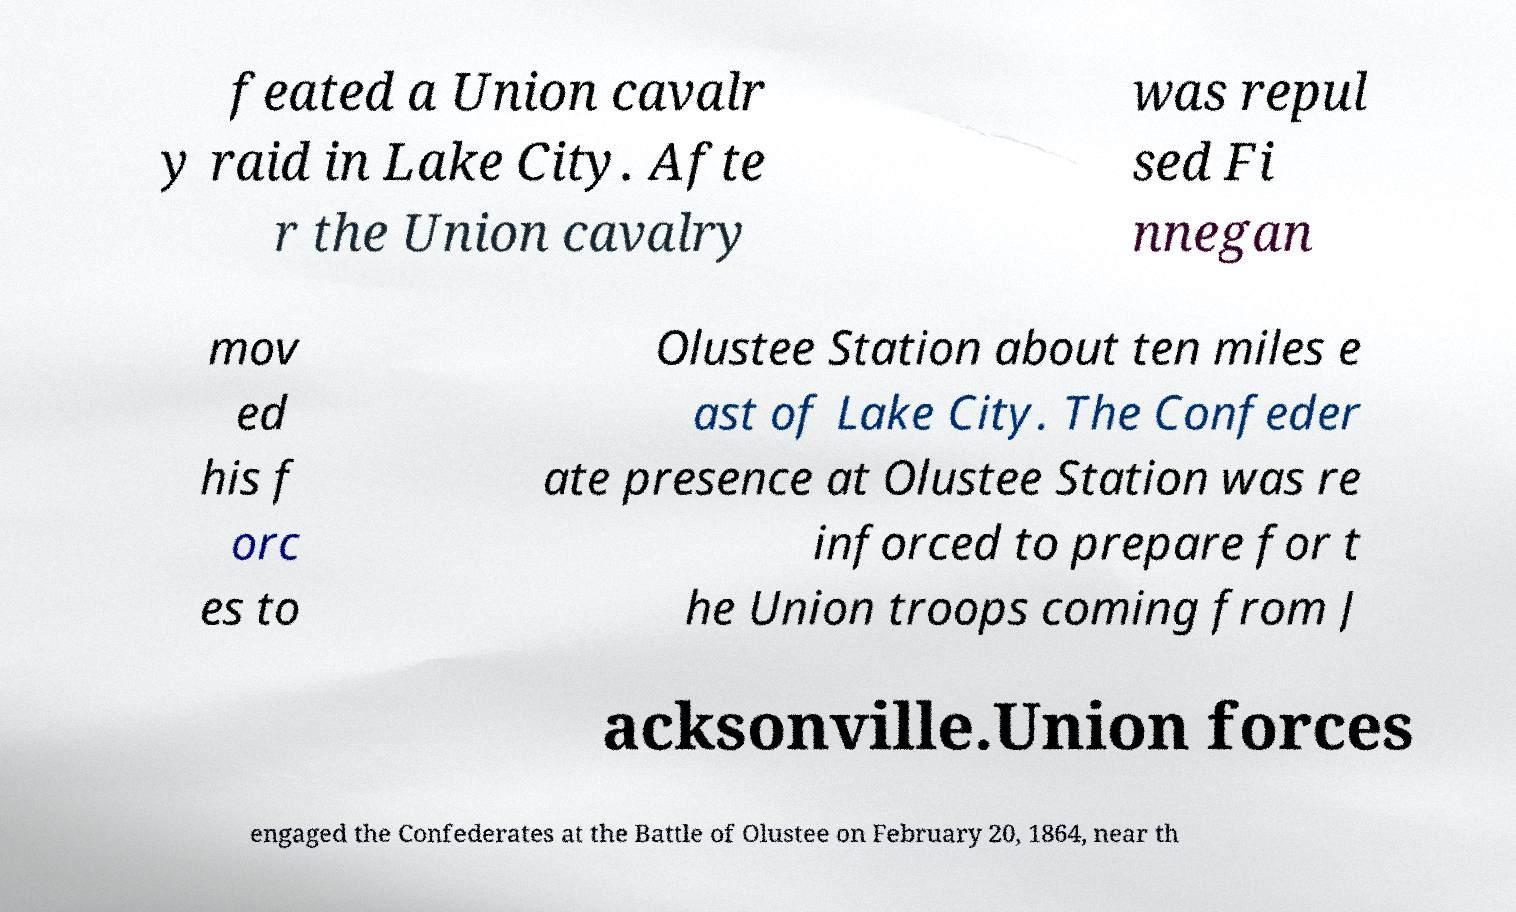Please read and relay the text visible in this image. What does it say? feated a Union cavalr y raid in Lake City. Afte r the Union cavalry was repul sed Fi nnegan mov ed his f orc es to Olustee Station about ten miles e ast of Lake City. The Confeder ate presence at Olustee Station was re inforced to prepare for t he Union troops coming from J acksonville.Union forces engaged the Confederates at the Battle of Olustee on February 20, 1864, near th 